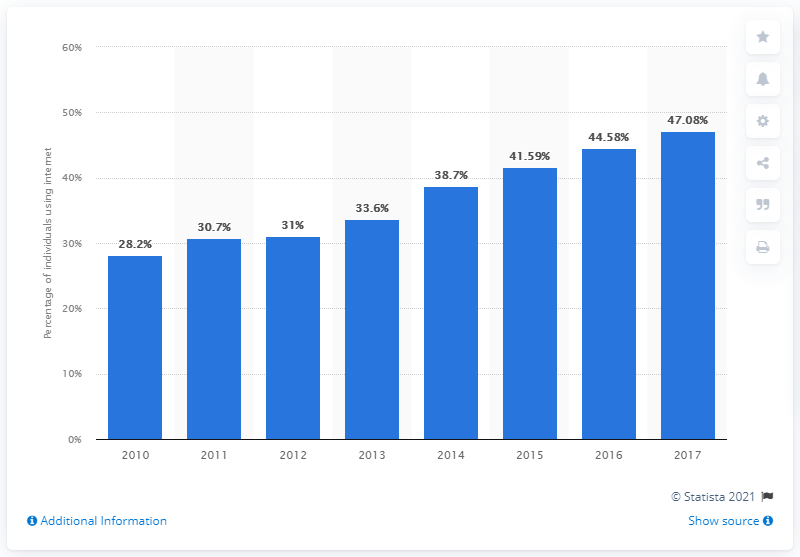Identify some key points in this picture. In 2010, approximately 28.2% of Belize's population accessed the internet. 